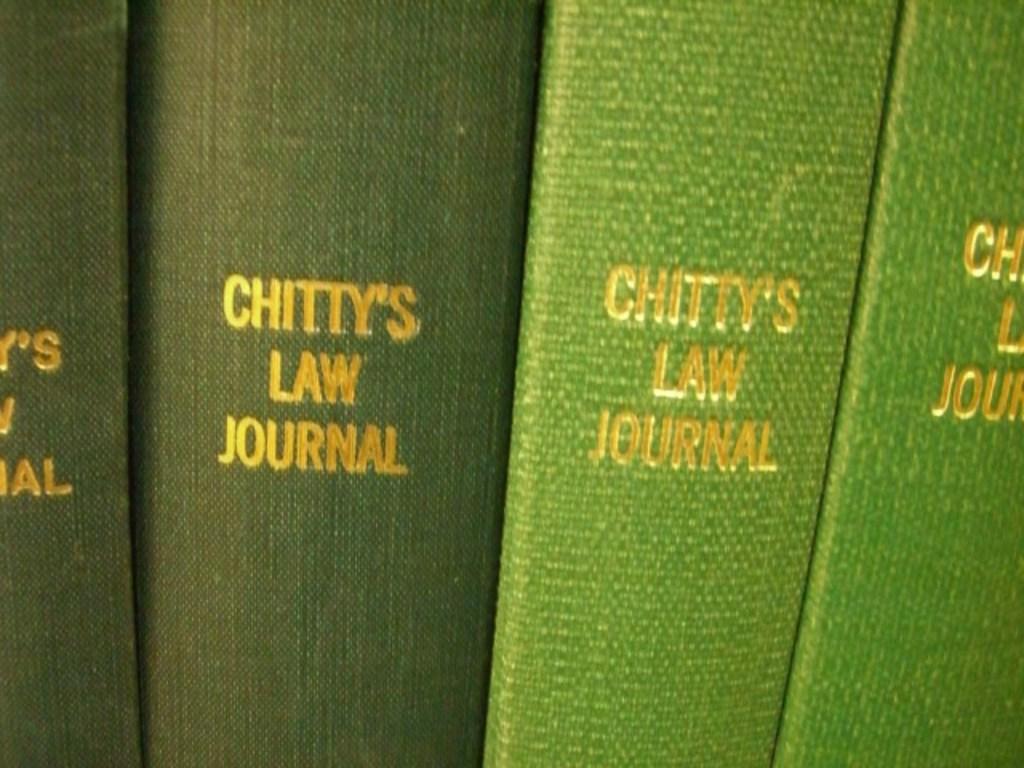Who's law journal?
Your answer should be compact. Chitty's. What kind of book is this?
Your answer should be compact. Chitty's law journal. 